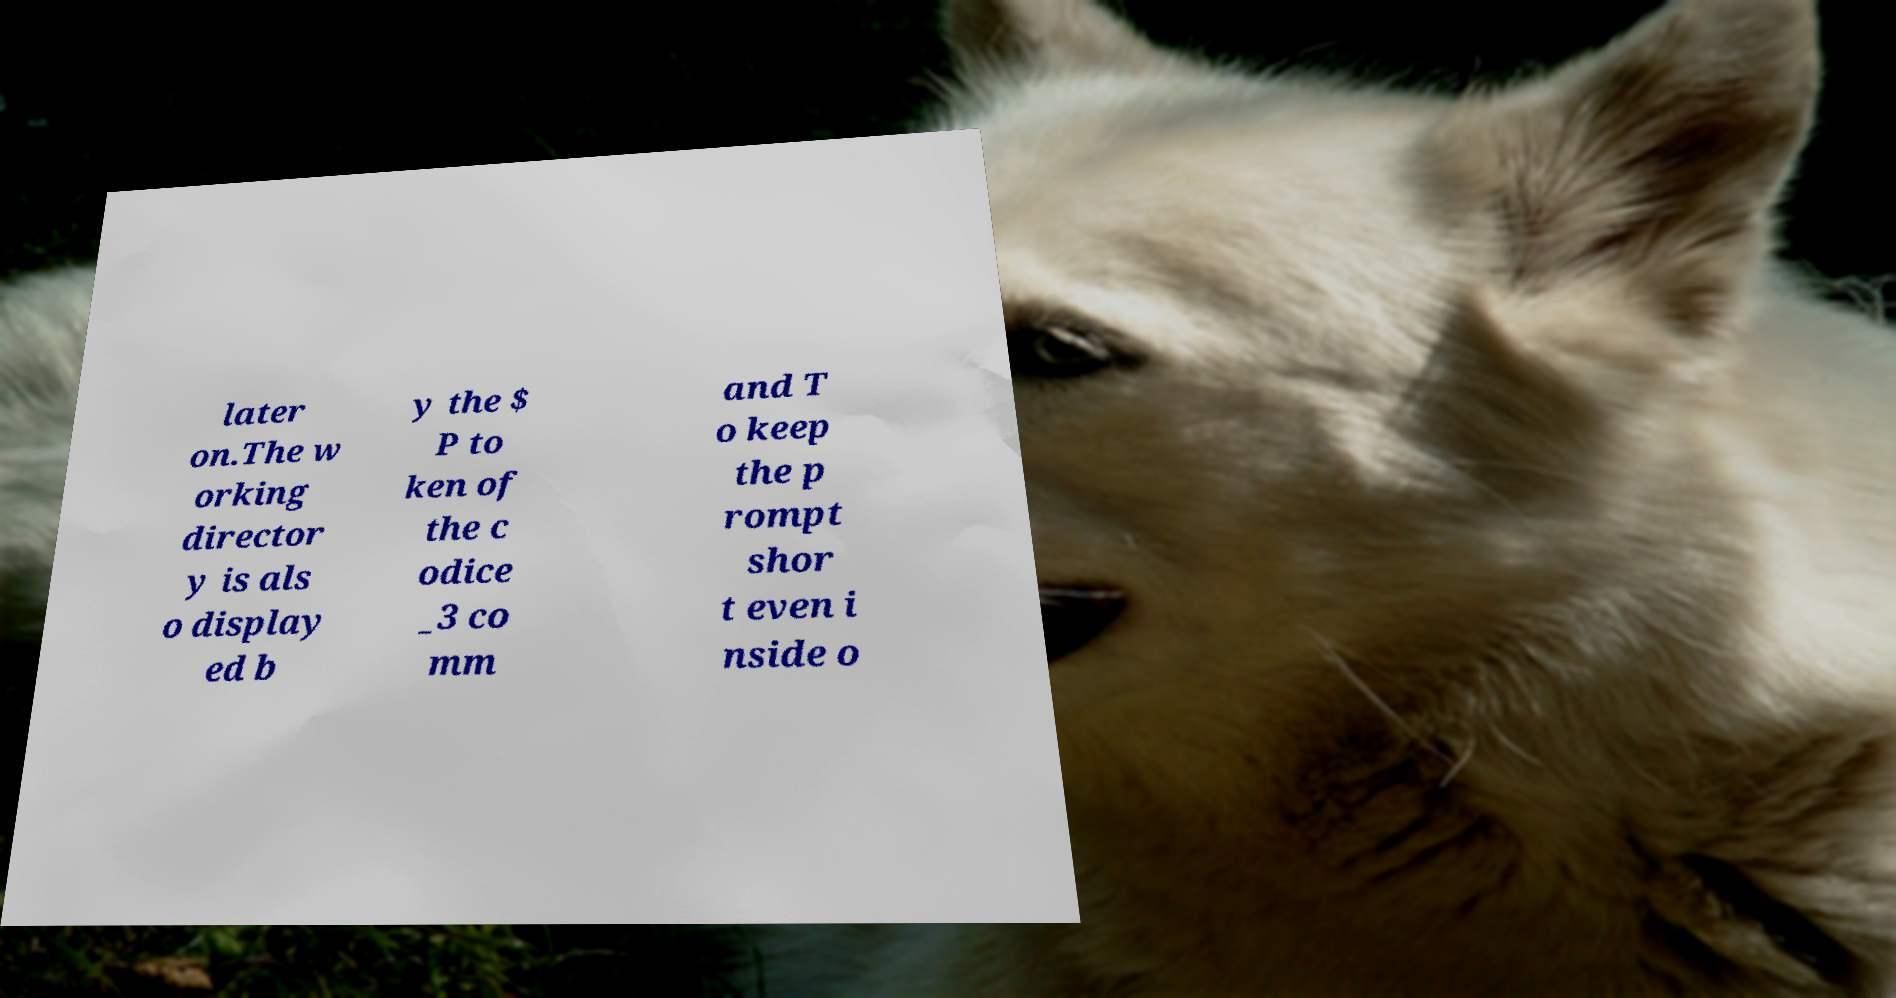There's text embedded in this image that I need extracted. Can you transcribe it verbatim? later on.The w orking director y is als o display ed b y the $ P to ken of the c odice _3 co mm and T o keep the p rompt shor t even i nside o 